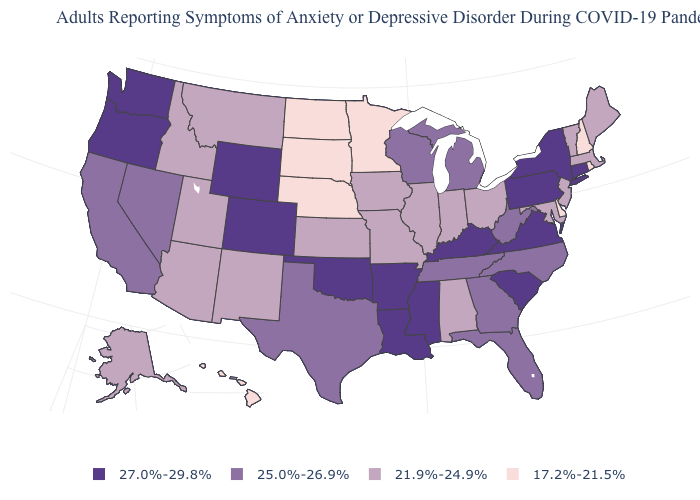What is the lowest value in states that border Virginia?
Short answer required. 21.9%-24.9%. What is the value of Oregon?
Answer briefly. 27.0%-29.8%. What is the value of Vermont?
Write a very short answer. 21.9%-24.9%. Does Nebraska have a higher value than Kansas?
Keep it brief. No. Does Louisiana have the lowest value in the USA?
Quick response, please. No. What is the value of Nebraska?
Short answer required. 17.2%-21.5%. What is the lowest value in the USA?
Keep it brief. 17.2%-21.5%. What is the value of Nevada?
Short answer required. 25.0%-26.9%. Name the states that have a value in the range 17.2%-21.5%?
Be succinct. Delaware, Hawaii, Minnesota, Nebraska, New Hampshire, North Dakota, Rhode Island, South Dakota. What is the value of Florida?
Be succinct. 25.0%-26.9%. What is the highest value in the MidWest ?
Answer briefly. 25.0%-26.9%. Does South Carolina have the same value as Maryland?
Keep it brief. No. Does the map have missing data?
Quick response, please. No. Name the states that have a value in the range 17.2%-21.5%?
Answer briefly. Delaware, Hawaii, Minnesota, Nebraska, New Hampshire, North Dakota, Rhode Island, South Dakota. What is the value of Georgia?
Be succinct. 25.0%-26.9%. 